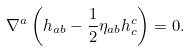<formula> <loc_0><loc_0><loc_500><loc_500>\nabla ^ { a } \left ( h _ { a b } - \frac { 1 } { 2 } \eta _ { a b } h _ { c } ^ { c } \right ) = 0 .</formula> 